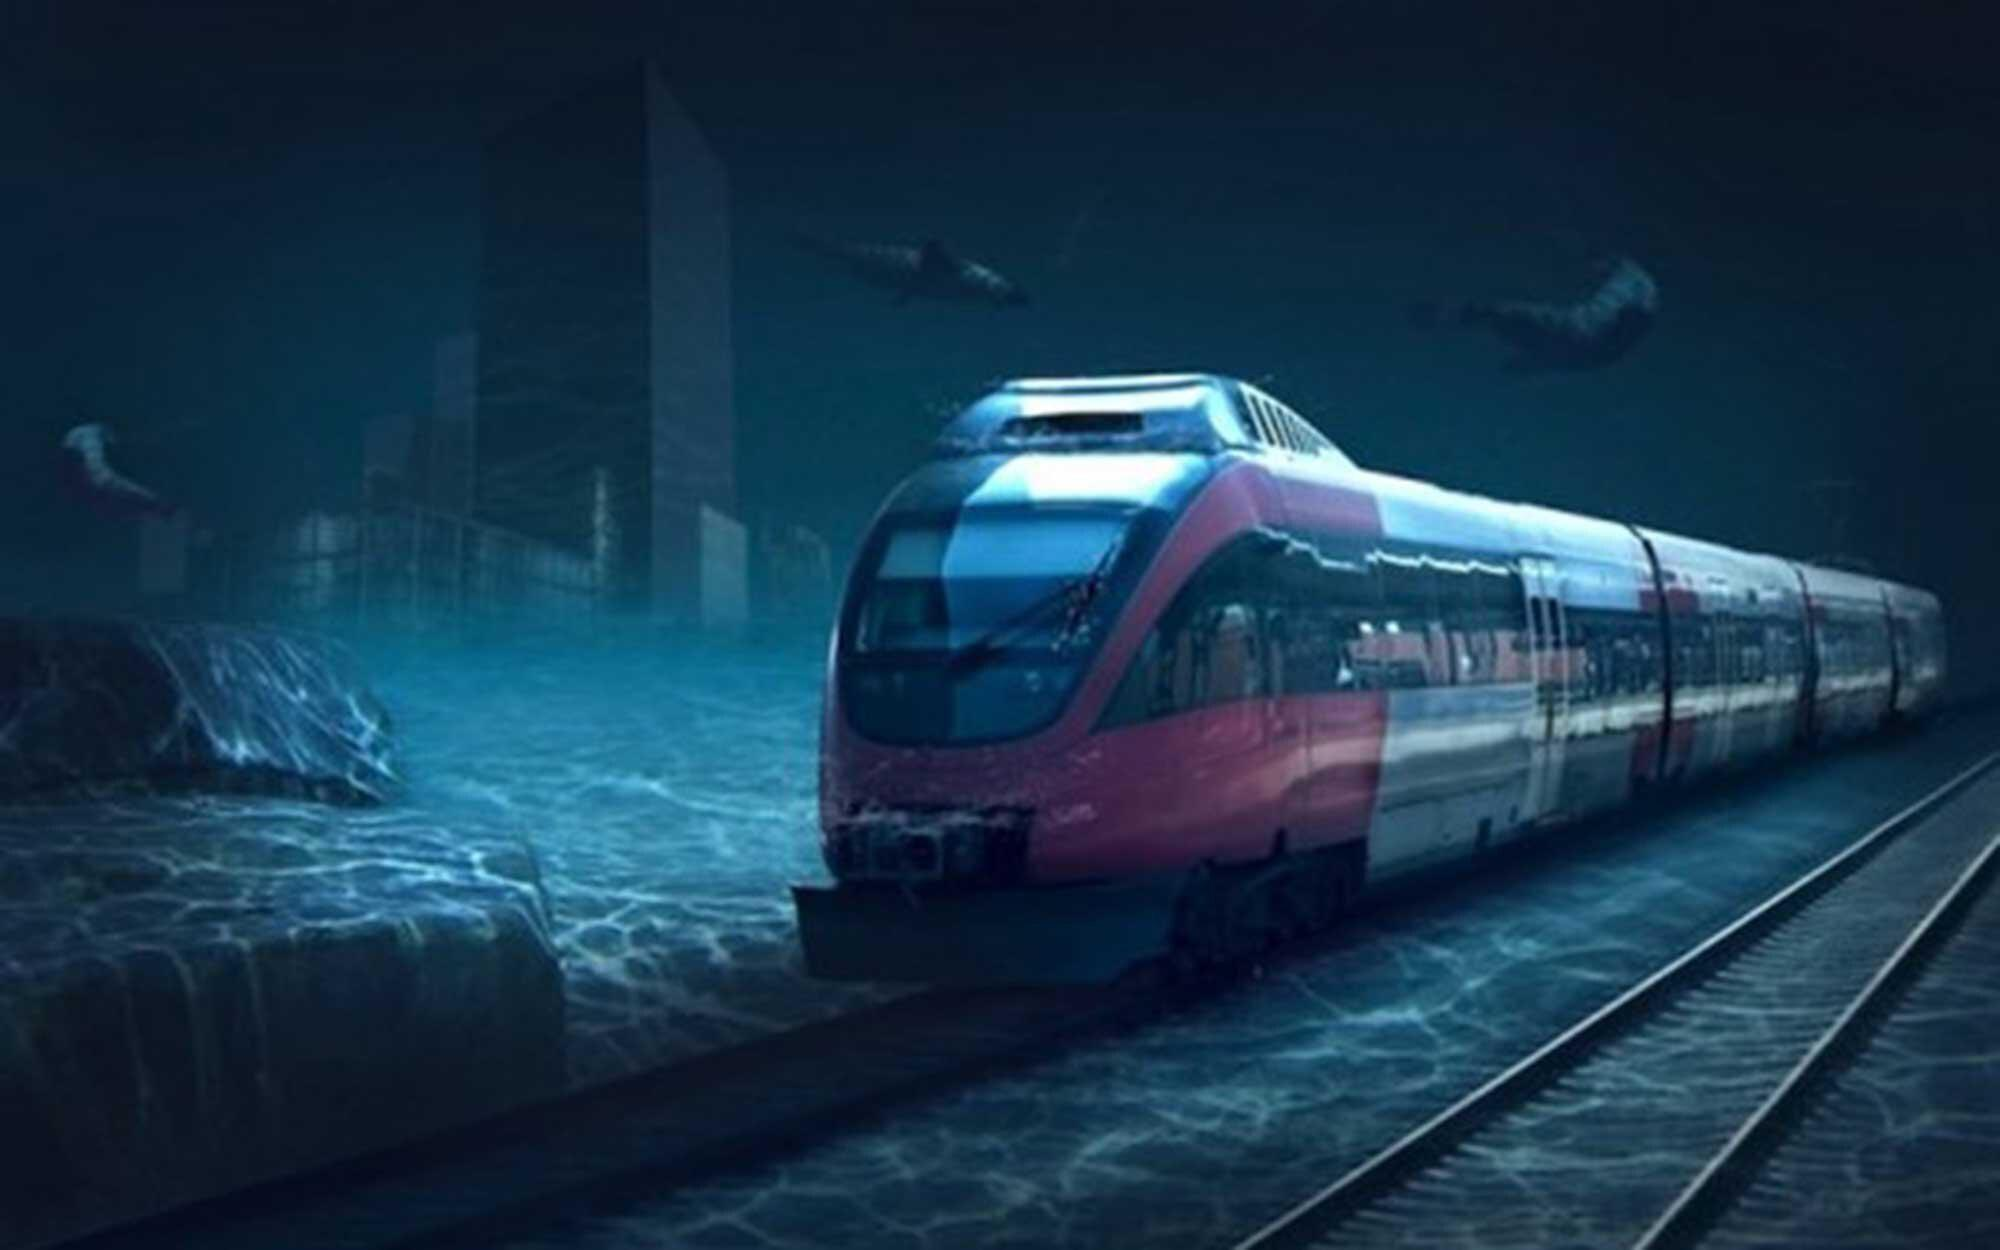What emotions does this image evoke? This image evokes a mix of emotions. While there is a haunting beauty to the stillness of the water and the adaptability demonstrated by the train, there's also a sense of solitude and loss. The submerged buildings suggest a dramatic change in the world that has left the usual bustling city life quiet and dormant. It's nostalgic and serene, yet also somewhat unsettling, as it prompts reflection on the power of nature and the resilience needed in the face of change. 